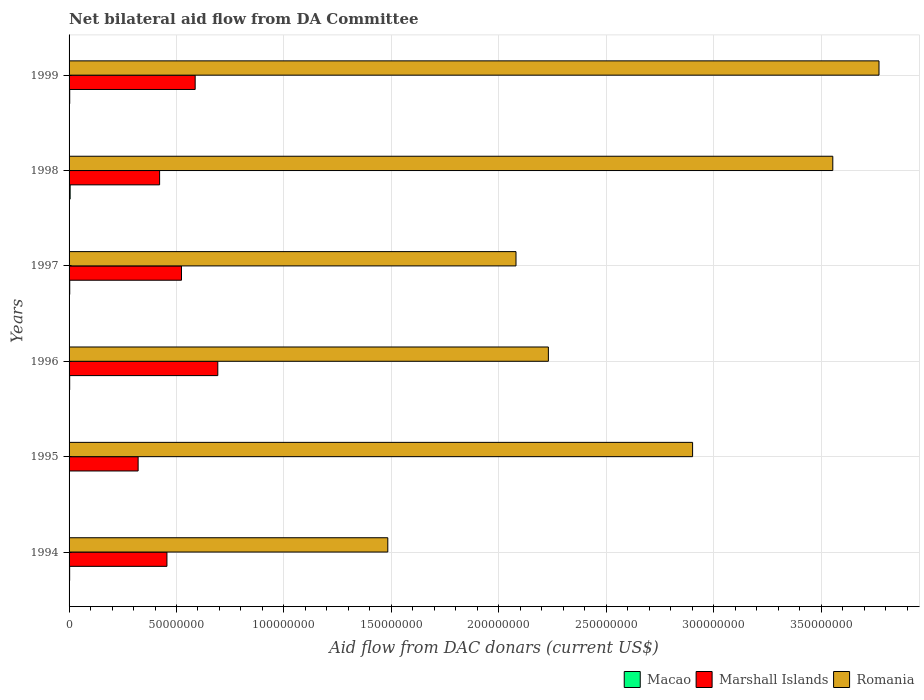How many different coloured bars are there?
Provide a succinct answer. 3. Are the number of bars on each tick of the Y-axis equal?
Give a very brief answer. Yes. How many bars are there on the 4th tick from the bottom?
Give a very brief answer. 3. In how many cases, is the number of bars for a given year not equal to the number of legend labels?
Your answer should be compact. 0. What is the aid flow in in Romania in 1998?
Keep it short and to the point. 3.55e+08. Across all years, what is the maximum aid flow in in Marshall Islands?
Your answer should be very brief. 6.92e+07. Across all years, what is the minimum aid flow in in Romania?
Provide a short and direct response. 1.48e+08. In which year was the aid flow in in Romania maximum?
Provide a succinct answer. 1999. What is the total aid flow in in Romania in the graph?
Your response must be concise. 1.60e+09. What is the difference between the aid flow in in Romania in 1994 and that in 1996?
Your answer should be compact. -7.47e+07. What is the difference between the aid flow in in Marshall Islands in 1994 and the aid flow in in Romania in 1995?
Your answer should be very brief. -2.45e+08. What is the average aid flow in in Macao per year?
Make the answer very short. 3.02e+05. In the year 1999, what is the difference between the aid flow in in Macao and aid flow in in Romania?
Offer a very short reply. -3.77e+08. In how many years, is the aid flow in in Romania greater than 270000000 US$?
Provide a succinct answer. 3. What is the ratio of the aid flow in in Macao in 1995 to that in 1998?
Your answer should be very brief. 0.28. What is the difference between the highest and the second highest aid flow in in Marshall Islands?
Keep it short and to the point. 1.05e+07. What is the difference between the highest and the lowest aid flow in in Romania?
Keep it short and to the point. 2.29e+08. In how many years, is the aid flow in in Romania greater than the average aid flow in in Romania taken over all years?
Your answer should be very brief. 3. Is the sum of the aid flow in in Marshall Islands in 1994 and 1997 greater than the maximum aid flow in in Romania across all years?
Offer a very short reply. No. What does the 2nd bar from the top in 1999 represents?
Your answer should be very brief. Marshall Islands. What does the 1st bar from the bottom in 1994 represents?
Offer a terse response. Macao. Is it the case that in every year, the sum of the aid flow in in Macao and aid flow in in Romania is greater than the aid flow in in Marshall Islands?
Your response must be concise. Yes. How many bars are there?
Keep it short and to the point. 18. How many years are there in the graph?
Your answer should be compact. 6. What is the difference between two consecutive major ticks on the X-axis?
Make the answer very short. 5.00e+07. Does the graph contain any zero values?
Make the answer very short. No. Does the graph contain grids?
Provide a succinct answer. Yes. Where does the legend appear in the graph?
Offer a very short reply. Bottom right. How are the legend labels stacked?
Give a very brief answer. Horizontal. What is the title of the graph?
Ensure brevity in your answer.  Net bilateral aid flow from DA Committee. Does "Czech Republic" appear as one of the legend labels in the graph?
Offer a very short reply. No. What is the label or title of the X-axis?
Make the answer very short. Aid flow from DAC donars (current US$). What is the label or title of the Y-axis?
Your answer should be compact. Years. What is the Aid flow from DAC donars (current US$) of Macao in 1994?
Make the answer very short. 2.70e+05. What is the Aid flow from DAC donars (current US$) of Marshall Islands in 1994?
Keep it short and to the point. 4.56e+07. What is the Aid flow from DAC donars (current US$) of Romania in 1994?
Ensure brevity in your answer.  1.48e+08. What is the Aid flow from DAC donars (current US$) of Macao in 1995?
Your answer should be compact. 1.40e+05. What is the Aid flow from DAC donars (current US$) in Marshall Islands in 1995?
Give a very brief answer. 3.21e+07. What is the Aid flow from DAC donars (current US$) of Romania in 1995?
Make the answer very short. 2.90e+08. What is the Aid flow from DAC donars (current US$) of Macao in 1996?
Provide a succinct answer. 2.90e+05. What is the Aid flow from DAC donars (current US$) in Marshall Islands in 1996?
Keep it short and to the point. 6.92e+07. What is the Aid flow from DAC donars (current US$) in Romania in 1996?
Your answer should be very brief. 2.23e+08. What is the Aid flow from DAC donars (current US$) in Marshall Islands in 1997?
Provide a short and direct response. 5.23e+07. What is the Aid flow from DAC donars (current US$) of Romania in 1997?
Ensure brevity in your answer.  2.08e+08. What is the Aid flow from DAC donars (current US$) of Macao in 1998?
Your answer should be very brief. 5.00e+05. What is the Aid flow from DAC donars (current US$) of Marshall Islands in 1998?
Make the answer very short. 4.21e+07. What is the Aid flow from DAC donars (current US$) in Romania in 1998?
Keep it short and to the point. 3.55e+08. What is the Aid flow from DAC donars (current US$) in Macao in 1999?
Offer a very short reply. 3.00e+05. What is the Aid flow from DAC donars (current US$) of Marshall Islands in 1999?
Make the answer very short. 5.87e+07. What is the Aid flow from DAC donars (current US$) in Romania in 1999?
Your answer should be compact. 3.77e+08. Across all years, what is the maximum Aid flow from DAC donars (current US$) in Macao?
Your response must be concise. 5.00e+05. Across all years, what is the maximum Aid flow from DAC donars (current US$) in Marshall Islands?
Give a very brief answer. 6.92e+07. Across all years, what is the maximum Aid flow from DAC donars (current US$) of Romania?
Provide a short and direct response. 3.77e+08. Across all years, what is the minimum Aid flow from DAC donars (current US$) of Macao?
Keep it short and to the point. 1.40e+05. Across all years, what is the minimum Aid flow from DAC donars (current US$) of Marshall Islands?
Give a very brief answer. 3.21e+07. Across all years, what is the minimum Aid flow from DAC donars (current US$) of Romania?
Your answer should be very brief. 1.48e+08. What is the total Aid flow from DAC donars (current US$) in Macao in the graph?
Offer a very short reply. 1.81e+06. What is the total Aid flow from DAC donars (current US$) of Marshall Islands in the graph?
Provide a short and direct response. 3.00e+08. What is the total Aid flow from DAC donars (current US$) of Romania in the graph?
Your response must be concise. 1.60e+09. What is the difference between the Aid flow from DAC donars (current US$) in Marshall Islands in 1994 and that in 1995?
Keep it short and to the point. 1.34e+07. What is the difference between the Aid flow from DAC donars (current US$) in Romania in 1994 and that in 1995?
Provide a succinct answer. -1.42e+08. What is the difference between the Aid flow from DAC donars (current US$) of Macao in 1994 and that in 1996?
Provide a short and direct response. -2.00e+04. What is the difference between the Aid flow from DAC donars (current US$) of Marshall Islands in 1994 and that in 1996?
Offer a very short reply. -2.37e+07. What is the difference between the Aid flow from DAC donars (current US$) in Romania in 1994 and that in 1996?
Your response must be concise. -7.47e+07. What is the difference between the Aid flow from DAC donars (current US$) in Macao in 1994 and that in 1997?
Offer a very short reply. -4.00e+04. What is the difference between the Aid flow from DAC donars (current US$) in Marshall Islands in 1994 and that in 1997?
Your answer should be very brief. -6.77e+06. What is the difference between the Aid flow from DAC donars (current US$) in Romania in 1994 and that in 1997?
Keep it short and to the point. -5.97e+07. What is the difference between the Aid flow from DAC donars (current US$) of Marshall Islands in 1994 and that in 1998?
Ensure brevity in your answer.  3.41e+06. What is the difference between the Aid flow from DAC donars (current US$) in Romania in 1994 and that in 1998?
Your answer should be compact. -2.07e+08. What is the difference between the Aid flow from DAC donars (current US$) of Marshall Islands in 1994 and that in 1999?
Provide a short and direct response. -1.31e+07. What is the difference between the Aid flow from DAC donars (current US$) in Romania in 1994 and that in 1999?
Your response must be concise. -2.29e+08. What is the difference between the Aid flow from DAC donars (current US$) of Macao in 1995 and that in 1996?
Offer a terse response. -1.50e+05. What is the difference between the Aid flow from DAC donars (current US$) of Marshall Islands in 1995 and that in 1996?
Offer a very short reply. -3.71e+07. What is the difference between the Aid flow from DAC donars (current US$) in Romania in 1995 and that in 1996?
Your answer should be compact. 6.71e+07. What is the difference between the Aid flow from DAC donars (current US$) in Marshall Islands in 1995 and that in 1997?
Offer a very short reply. -2.02e+07. What is the difference between the Aid flow from DAC donars (current US$) of Romania in 1995 and that in 1997?
Offer a terse response. 8.22e+07. What is the difference between the Aid flow from DAC donars (current US$) in Macao in 1995 and that in 1998?
Provide a short and direct response. -3.60e+05. What is the difference between the Aid flow from DAC donars (current US$) of Marshall Islands in 1995 and that in 1998?
Provide a short and direct response. -1.00e+07. What is the difference between the Aid flow from DAC donars (current US$) of Romania in 1995 and that in 1998?
Your answer should be compact. -6.53e+07. What is the difference between the Aid flow from DAC donars (current US$) in Macao in 1995 and that in 1999?
Your response must be concise. -1.60e+05. What is the difference between the Aid flow from DAC donars (current US$) in Marshall Islands in 1995 and that in 1999?
Ensure brevity in your answer.  -2.66e+07. What is the difference between the Aid flow from DAC donars (current US$) in Romania in 1995 and that in 1999?
Your response must be concise. -8.68e+07. What is the difference between the Aid flow from DAC donars (current US$) of Marshall Islands in 1996 and that in 1997?
Your response must be concise. 1.69e+07. What is the difference between the Aid flow from DAC donars (current US$) in Romania in 1996 and that in 1997?
Offer a terse response. 1.51e+07. What is the difference between the Aid flow from DAC donars (current US$) in Marshall Islands in 1996 and that in 1998?
Your answer should be compact. 2.71e+07. What is the difference between the Aid flow from DAC donars (current US$) of Romania in 1996 and that in 1998?
Your answer should be compact. -1.32e+08. What is the difference between the Aid flow from DAC donars (current US$) in Macao in 1996 and that in 1999?
Give a very brief answer. -10000. What is the difference between the Aid flow from DAC donars (current US$) in Marshall Islands in 1996 and that in 1999?
Your answer should be compact. 1.05e+07. What is the difference between the Aid flow from DAC donars (current US$) in Romania in 1996 and that in 1999?
Offer a very short reply. -1.54e+08. What is the difference between the Aid flow from DAC donars (current US$) in Macao in 1997 and that in 1998?
Keep it short and to the point. -1.90e+05. What is the difference between the Aid flow from DAC donars (current US$) in Marshall Islands in 1997 and that in 1998?
Offer a terse response. 1.02e+07. What is the difference between the Aid flow from DAC donars (current US$) in Romania in 1997 and that in 1998?
Provide a short and direct response. -1.47e+08. What is the difference between the Aid flow from DAC donars (current US$) in Marshall Islands in 1997 and that in 1999?
Provide a succinct answer. -6.37e+06. What is the difference between the Aid flow from DAC donars (current US$) in Romania in 1997 and that in 1999?
Keep it short and to the point. -1.69e+08. What is the difference between the Aid flow from DAC donars (current US$) in Marshall Islands in 1998 and that in 1999?
Give a very brief answer. -1.66e+07. What is the difference between the Aid flow from DAC donars (current US$) in Romania in 1998 and that in 1999?
Keep it short and to the point. -2.15e+07. What is the difference between the Aid flow from DAC donars (current US$) in Macao in 1994 and the Aid flow from DAC donars (current US$) in Marshall Islands in 1995?
Provide a short and direct response. -3.19e+07. What is the difference between the Aid flow from DAC donars (current US$) of Macao in 1994 and the Aid flow from DAC donars (current US$) of Romania in 1995?
Your response must be concise. -2.90e+08. What is the difference between the Aid flow from DAC donars (current US$) of Marshall Islands in 1994 and the Aid flow from DAC donars (current US$) of Romania in 1995?
Provide a succinct answer. -2.45e+08. What is the difference between the Aid flow from DAC donars (current US$) in Macao in 1994 and the Aid flow from DAC donars (current US$) in Marshall Islands in 1996?
Your response must be concise. -6.90e+07. What is the difference between the Aid flow from DAC donars (current US$) in Macao in 1994 and the Aid flow from DAC donars (current US$) in Romania in 1996?
Provide a succinct answer. -2.23e+08. What is the difference between the Aid flow from DAC donars (current US$) of Marshall Islands in 1994 and the Aid flow from DAC donars (current US$) of Romania in 1996?
Make the answer very short. -1.78e+08. What is the difference between the Aid flow from DAC donars (current US$) in Macao in 1994 and the Aid flow from DAC donars (current US$) in Marshall Islands in 1997?
Provide a short and direct response. -5.20e+07. What is the difference between the Aid flow from DAC donars (current US$) in Macao in 1994 and the Aid flow from DAC donars (current US$) in Romania in 1997?
Give a very brief answer. -2.08e+08. What is the difference between the Aid flow from DAC donars (current US$) in Marshall Islands in 1994 and the Aid flow from DAC donars (current US$) in Romania in 1997?
Your answer should be compact. -1.62e+08. What is the difference between the Aid flow from DAC donars (current US$) in Macao in 1994 and the Aid flow from DAC donars (current US$) in Marshall Islands in 1998?
Your answer should be compact. -4.19e+07. What is the difference between the Aid flow from DAC donars (current US$) of Macao in 1994 and the Aid flow from DAC donars (current US$) of Romania in 1998?
Your response must be concise. -3.55e+08. What is the difference between the Aid flow from DAC donars (current US$) of Marshall Islands in 1994 and the Aid flow from DAC donars (current US$) of Romania in 1998?
Offer a very short reply. -3.10e+08. What is the difference between the Aid flow from DAC donars (current US$) of Macao in 1994 and the Aid flow from DAC donars (current US$) of Marshall Islands in 1999?
Provide a short and direct response. -5.84e+07. What is the difference between the Aid flow from DAC donars (current US$) of Macao in 1994 and the Aid flow from DAC donars (current US$) of Romania in 1999?
Your answer should be compact. -3.77e+08. What is the difference between the Aid flow from DAC donars (current US$) of Marshall Islands in 1994 and the Aid flow from DAC donars (current US$) of Romania in 1999?
Give a very brief answer. -3.31e+08. What is the difference between the Aid flow from DAC donars (current US$) in Macao in 1995 and the Aid flow from DAC donars (current US$) in Marshall Islands in 1996?
Your response must be concise. -6.91e+07. What is the difference between the Aid flow from DAC donars (current US$) in Macao in 1995 and the Aid flow from DAC donars (current US$) in Romania in 1996?
Ensure brevity in your answer.  -2.23e+08. What is the difference between the Aid flow from DAC donars (current US$) of Marshall Islands in 1995 and the Aid flow from DAC donars (current US$) of Romania in 1996?
Provide a short and direct response. -1.91e+08. What is the difference between the Aid flow from DAC donars (current US$) in Macao in 1995 and the Aid flow from DAC donars (current US$) in Marshall Islands in 1997?
Provide a succinct answer. -5.22e+07. What is the difference between the Aid flow from DAC donars (current US$) of Macao in 1995 and the Aid flow from DAC donars (current US$) of Romania in 1997?
Provide a succinct answer. -2.08e+08. What is the difference between the Aid flow from DAC donars (current US$) of Marshall Islands in 1995 and the Aid flow from DAC donars (current US$) of Romania in 1997?
Make the answer very short. -1.76e+08. What is the difference between the Aid flow from DAC donars (current US$) in Macao in 1995 and the Aid flow from DAC donars (current US$) in Marshall Islands in 1998?
Ensure brevity in your answer.  -4.20e+07. What is the difference between the Aid flow from DAC donars (current US$) in Macao in 1995 and the Aid flow from DAC donars (current US$) in Romania in 1998?
Offer a very short reply. -3.55e+08. What is the difference between the Aid flow from DAC donars (current US$) in Marshall Islands in 1995 and the Aid flow from DAC donars (current US$) in Romania in 1998?
Keep it short and to the point. -3.23e+08. What is the difference between the Aid flow from DAC donars (current US$) in Macao in 1995 and the Aid flow from DAC donars (current US$) in Marshall Islands in 1999?
Keep it short and to the point. -5.86e+07. What is the difference between the Aid flow from DAC donars (current US$) of Macao in 1995 and the Aid flow from DAC donars (current US$) of Romania in 1999?
Your answer should be very brief. -3.77e+08. What is the difference between the Aid flow from DAC donars (current US$) in Marshall Islands in 1995 and the Aid flow from DAC donars (current US$) in Romania in 1999?
Keep it short and to the point. -3.45e+08. What is the difference between the Aid flow from DAC donars (current US$) in Macao in 1996 and the Aid flow from DAC donars (current US$) in Marshall Islands in 1997?
Give a very brief answer. -5.20e+07. What is the difference between the Aid flow from DAC donars (current US$) in Macao in 1996 and the Aid flow from DAC donars (current US$) in Romania in 1997?
Provide a short and direct response. -2.08e+08. What is the difference between the Aid flow from DAC donars (current US$) in Marshall Islands in 1996 and the Aid flow from DAC donars (current US$) in Romania in 1997?
Offer a very short reply. -1.39e+08. What is the difference between the Aid flow from DAC donars (current US$) in Macao in 1996 and the Aid flow from DAC donars (current US$) in Marshall Islands in 1998?
Your answer should be very brief. -4.18e+07. What is the difference between the Aid flow from DAC donars (current US$) in Macao in 1996 and the Aid flow from DAC donars (current US$) in Romania in 1998?
Provide a short and direct response. -3.55e+08. What is the difference between the Aid flow from DAC donars (current US$) of Marshall Islands in 1996 and the Aid flow from DAC donars (current US$) of Romania in 1998?
Provide a short and direct response. -2.86e+08. What is the difference between the Aid flow from DAC donars (current US$) in Macao in 1996 and the Aid flow from DAC donars (current US$) in Marshall Islands in 1999?
Make the answer very short. -5.84e+07. What is the difference between the Aid flow from DAC donars (current US$) in Macao in 1996 and the Aid flow from DAC donars (current US$) in Romania in 1999?
Your answer should be compact. -3.77e+08. What is the difference between the Aid flow from DAC donars (current US$) in Marshall Islands in 1996 and the Aid flow from DAC donars (current US$) in Romania in 1999?
Provide a succinct answer. -3.08e+08. What is the difference between the Aid flow from DAC donars (current US$) in Macao in 1997 and the Aid flow from DAC donars (current US$) in Marshall Islands in 1998?
Give a very brief answer. -4.18e+07. What is the difference between the Aid flow from DAC donars (current US$) in Macao in 1997 and the Aid flow from DAC donars (current US$) in Romania in 1998?
Give a very brief answer. -3.55e+08. What is the difference between the Aid flow from DAC donars (current US$) in Marshall Islands in 1997 and the Aid flow from DAC donars (current US$) in Romania in 1998?
Provide a short and direct response. -3.03e+08. What is the difference between the Aid flow from DAC donars (current US$) of Macao in 1997 and the Aid flow from DAC donars (current US$) of Marshall Islands in 1999?
Give a very brief answer. -5.84e+07. What is the difference between the Aid flow from DAC donars (current US$) in Macao in 1997 and the Aid flow from DAC donars (current US$) in Romania in 1999?
Offer a terse response. -3.77e+08. What is the difference between the Aid flow from DAC donars (current US$) in Marshall Islands in 1997 and the Aid flow from DAC donars (current US$) in Romania in 1999?
Your answer should be compact. -3.25e+08. What is the difference between the Aid flow from DAC donars (current US$) of Macao in 1998 and the Aid flow from DAC donars (current US$) of Marshall Islands in 1999?
Offer a terse response. -5.82e+07. What is the difference between the Aid flow from DAC donars (current US$) in Macao in 1998 and the Aid flow from DAC donars (current US$) in Romania in 1999?
Keep it short and to the point. -3.76e+08. What is the difference between the Aid flow from DAC donars (current US$) in Marshall Islands in 1998 and the Aid flow from DAC donars (current US$) in Romania in 1999?
Offer a terse response. -3.35e+08. What is the average Aid flow from DAC donars (current US$) of Macao per year?
Make the answer very short. 3.02e+05. What is the average Aid flow from DAC donars (current US$) of Marshall Islands per year?
Ensure brevity in your answer.  5.00e+07. What is the average Aid flow from DAC donars (current US$) of Romania per year?
Ensure brevity in your answer.  2.67e+08. In the year 1994, what is the difference between the Aid flow from DAC donars (current US$) in Macao and Aid flow from DAC donars (current US$) in Marshall Islands?
Your response must be concise. -4.53e+07. In the year 1994, what is the difference between the Aid flow from DAC donars (current US$) in Macao and Aid flow from DAC donars (current US$) in Romania?
Provide a succinct answer. -1.48e+08. In the year 1994, what is the difference between the Aid flow from DAC donars (current US$) in Marshall Islands and Aid flow from DAC donars (current US$) in Romania?
Give a very brief answer. -1.03e+08. In the year 1995, what is the difference between the Aid flow from DAC donars (current US$) in Macao and Aid flow from DAC donars (current US$) in Marshall Islands?
Keep it short and to the point. -3.20e+07. In the year 1995, what is the difference between the Aid flow from DAC donars (current US$) of Macao and Aid flow from DAC donars (current US$) of Romania?
Keep it short and to the point. -2.90e+08. In the year 1995, what is the difference between the Aid flow from DAC donars (current US$) in Marshall Islands and Aid flow from DAC donars (current US$) in Romania?
Keep it short and to the point. -2.58e+08. In the year 1996, what is the difference between the Aid flow from DAC donars (current US$) of Macao and Aid flow from DAC donars (current US$) of Marshall Islands?
Provide a succinct answer. -6.89e+07. In the year 1996, what is the difference between the Aid flow from DAC donars (current US$) of Macao and Aid flow from DAC donars (current US$) of Romania?
Give a very brief answer. -2.23e+08. In the year 1996, what is the difference between the Aid flow from DAC donars (current US$) in Marshall Islands and Aid flow from DAC donars (current US$) in Romania?
Ensure brevity in your answer.  -1.54e+08. In the year 1997, what is the difference between the Aid flow from DAC donars (current US$) in Macao and Aid flow from DAC donars (current US$) in Marshall Islands?
Ensure brevity in your answer.  -5.20e+07. In the year 1997, what is the difference between the Aid flow from DAC donars (current US$) in Macao and Aid flow from DAC donars (current US$) in Romania?
Make the answer very short. -2.08e+08. In the year 1997, what is the difference between the Aid flow from DAC donars (current US$) in Marshall Islands and Aid flow from DAC donars (current US$) in Romania?
Provide a succinct answer. -1.56e+08. In the year 1998, what is the difference between the Aid flow from DAC donars (current US$) in Macao and Aid flow from DAC donars (current US$) in Marshall Islands?
Provide a short and direct response. -4.16e+07. In the year 1998, what is the difference between the Aid flow from DAC donars (current US$) in Macao and Aid flow from DAC donars (current US$) in Romania?
Your response must be concise. -3.55e+08. In the year 1998, what is the difference between the Aid flow from DAC donars (current US$) of Marshall Islands and Aid flow from DAC donars (current US$) of Romania?
Offer a terse response. -3.13e+08. In the year 1999, what is the difference between the Aid flow from DAC donars (current US$) in Macao and Aid flow from DAC donars (current US$) in Marshall Islands?
Provide a succinct answer. -5.84e+07. In the year 1999, what is the difference between the Aid flow from DAC donars (current US$) of Macao and Aid flow from DAC donars (current US$) of Romania?
Your answer should be very brief. -3.77e+08. In the year 1999, what is the difference between the Aid flow from DAC donars (current US$) in Marshall Islands and Aid flow from DAC donars (current US$) in Romania?
Provide a succinct answer. -3.18e+08. What is the ratio of the Aid flow from DAC donars (current US$) of Macao in 1994 to that in 1995?
Your answer should be very brief. 1.93. What is the ratio of the Aid flow from DAC donars (current US$) of Marshall Islands in 1994 to that in 1995?
Provide a short and direct response. 1.42. What is the ratio of the Aid flow from DAC donars (current US$) of Romania in 1994 to that in 1995?
Your answer should be compact. 0.51. What is the ratio of the Aid flow from DAC donars (current US$) of Macao in 1994 to that in 1996?
Give a very brief answer. 0.93. What is the ratio of the Aid flow from DAC donars (current US$) in Marshall Islands in 1994 to that in 1996?
Ensure brevity in your answer.  0.66. What is the ratio of the Aid flow from DAC donars (current US$) in Romania in 1994 to that in 1996?
Offer a very short reply. 0.67. What is the ratio of the Aid flow from DAC donars (current US$) in Macao in 1994 to that in 1997?
Provide a short and direct response. 0.87. What is the ratio of the Aid flow from DAC donars (current US$) of Marshall Islands in 1994 to that in 1997?
Your answer should be compact. 0.87. What is the ratio of the Aid flow from DAC donars (current US$) in Romania in 1994 to that in 1997?
Your answer should be very brief. 0.71. What is the ratio of the Aid flow from DAC donars (current US$) of Macao in 1994 to that in 1998?
Provide a succinct answer. 0.54. What is the ratio of the Aid flow from DAC donars (current US$) in Marshall Islands in 1994 to that in 1998?
Your answer should be compact. 1.08. What is the ratio of the Aid flow from DAC donars (current US$) in Romania in 1994 to that in 1998?
Your answer should be very brief. 0.42. What is the ratio of the Aid flow from DAC donars (current US$) in Marshall Islands in 1994 to that in 1999?
Offer a very short reply. 0.78. What is the ratio of the Aid flow from DAC donars (current US$) of Romania in 1994 to that in 1999?
Provide a succinct answer. 0.39. What is the ratio of the Aid flow from DAC donars (current US$) of Macao in 1995 to that in 1996?
Make the answer very short. 0.48. What is the ratio of the Aid flow from DAC donars (current US$) of Marshall Islands in 1995 to that in 1996?
Provide a short and direct response. 0.46. What is the ratio of the Aid flow from DAC donars (current US$) of Romania in 1995 to that in 1996?
Your answer should be very brief. 1.3. What is the ratio of the Aid flow from DAC donars (current US$) in Macao in 1995 to that in 1997?
Ensure brevity in your answer.  0.45. What is the ratio of the Aid flow from DAC donars (current US$) in Marshall Islands in 1995 to that in 1997?
Offer a very short reply. 0.61. What is the ratio of the Aid flow from DAC donars (current US$) of Romania in 1995 to that in 1997?
Give a very brief answer. 1.4. What is the ratio of the Aid flow from DAC donars (current US$) in Macao in 1995 to that in 1998?
Give a very brief answer. 0.28. What is the ratio of the Aid flow from DAC donars (current US$) in Marshall Islands in 1995 to that in 1998?
Your answer should be very brief. 0.76. What is the ratio of the Aid flow from DAC donars (current US$) in Romania in 1995 to that in 1998?
Keep it short and to the point. 0.82. What is the ratio of the Aid flow from DAC donars (current US$) in Macao in 1995 to that in 1999?
Offer a terse response. 0.47. What is the ratio of the Aid flow from DAC donars (current US$) of Marshall Islands in 1995 to that in 1999?
Ensure brevity in your answer.  0.55. What is the ratio of the Aid flow from DAC donars (current US$) in Romania in 1995 to that in 1999?
Keep it short and to the point. 0.77. What is the ratio of the Aid flow from DAC donars (current US$) of Macao in 1996 to that in 1997?
Your answer should be very brief. 0.94. What is the ratio of the Aid flow from DAC donars (current US$) of Marshall Islands in 1996 to that in 1997?
Your answer should be compact. 1.32. What is the ratio of the Aid flow from DAC donars (current US$) of Romania in 1996 to that in 1997?
Provide a short and direct response. 1.07. What is the ratio of the Aid flow from DAC donars (current US$) in Macao in 1996 to that in 1998?
Ensure brevity in your answer.  0.58. What is the ratio of the Aid flow from DAC donars (current US$) in Marshall Islands in 1996 to that in 1998?
Provide a succinct answer. 1.64. What is the ratio of the Aid flow from DAC donars (current US$) in Romania in 1996 to that in 1998?
Your answer should be very brief. 0.63. What is the ratio of the Aid flow from DAC donars (current US$) in Macao in 1996 to that in 1999?
Provide a succinct answer. 0.97. What is the ratio of the Aid flow from DAC donars (current US$) in Marshall Islands in 1996 to that in 1999?
Provide a succinct answer. 1.18. What is the ratio of the Aid flow from DAC donars (current US$) in Romania in 1996 to that in 1999?
Ensure brevity in your answer.  0.59. What is the ratio of the Aid flow from DAC donars (current US$) in Macao in 1997 to that in 1998?
Make the answer very short. 0.62. What is the ratio of the Aid flow from DAC donars (current US$) of Marshall Islands in 1997 to that in 1998?
Provide a short and direct response. 1.24. What is the ratio of the Aid flow from DAC donars (current US$) of Romania in 1997 to that in 1998?
Offer a terse response. 0.59. What is the ratio of the Aid flow from DAC donars (current US$) of Macao in 1997 to that in 1999?
Ensure brevity in your answer.  1.03. What is the ratio of the Aid flow from DAC donars (current US$) of Marshall Islands in 1997 to that in 1999?
Your answer should be very brief. 0.89. What is the ratio of the Aid flow from DAC donars (current US$) in Romania in 1997 to that in 1999?
Give a very brief answer. 0.55. What is the ratio of the Aid flow from DAC donars (current US$) in Marshall Islands in 1998 to that in 1999?
Keep it short and to the point. 0.72. What is the ratio of the Aid flow from DAC donars (current US$) in Romania in 1998 to that in 1999?
Give a very brief answer. 0.94. What is the difference between the highest and the second highest Aid flow from DAC donars (current US$) in Marshall Islands?
Ensure brevity in your answer.  1.05e+07. What is the difference between the highest and the second highest Aid flow from DAC donars (current US$) of Romania?
Provide a succinct answer. 2.15e+07. What is the difference between the highest and the lowest Aid flow from DAC donars (current US$) in Macao?
Provide a succinct answer. 3.60e+05. What is the difference between the highest and the lowest Aid flow from DAC donars (current US$) in Marshall Islands?
Your response must be concise. 3.71e+07. What is the difference between the highest and the lowest Aid flow from DAC donars (current US$) in Romania?
Provide a succinct answer. 2.29e+08. 